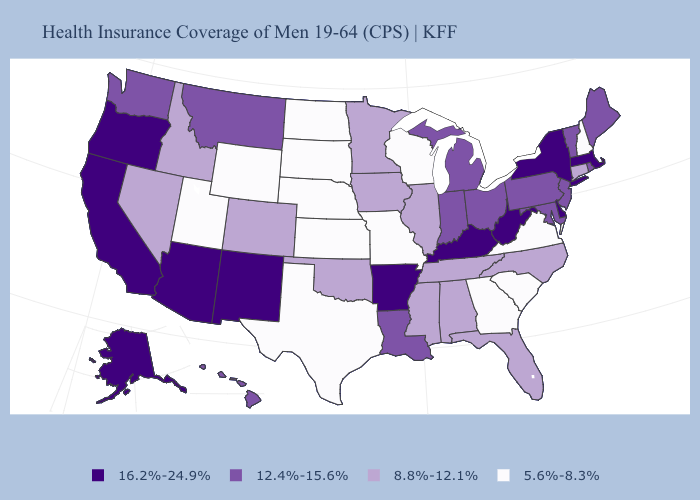Name the states that have a value in the range 5.6%-8.3%?
Concise answer only. Georgia, Kansas, Missouri, Nebraska, New Hampshire, North Dakota, South Carolina, South Dakota, Texas, Utah, Virginia, Wisconsin, Wyoming. What is the lowest value in the USA?
Be succinct. 5.6%-8.3%. Does West Virginia have the lowest value in the USA?
Keep it brief. No. Name the states that have a value in the range 16.2%-24.9%?
Short answer required. Alaska, Arizona, Arkansas, California, Delaware, Kentucky, Massachusetts, New Mexico, New York, Oregon, West Virginia. Name the states that have a value in the range 8.8%-12.1%?
Keep it brief. Alabama, Colorado, Connecticut, Florida, Idaho, Illinois, Iowa, Minnesota, Mississippi, Nevada, North Carolina, Oklahoma, Tennessee. What is the value of Texas?
Be succinct. 5.6%-8.3%. Among the states that border Colorado , which have the lowest value?
Short answer required. Kansas, Nebraska, Utah, Wyoming. Which states hav the highest value in the South?
Short answer required. Arkansas, Delaware, Kentucky, West Virginia. Among the states that border Vermont , does New Hampshire have the highest value?
Quick response, please. No. Name the states that have a value in the range 16.2%-24.9%?
Short answer required. Alaska, Arizona, Arkansas, California, Delaware, Kentucky, Massachusetts, New Mexico, New York, Oregon, West Virginia. Which states have the highest value in the USA?
Keep it brief. Alaska, Arizona, Arkansas, California, Delaware, Kentucky, Massachusetts, New Mexico, New York, Oregon, West Virginia. Does the first symbol in the legend represent the smallest category?
Give a very brief answer. No. Name the states that have a value in the range 12.4%-15.6%?
Keep it brief. Hawaii, Indiana, Louisiana, Maine, Maryland, Michigan, Montana, New Jersey, Ohio, Pennsylvania, Rhode Island, Vermont, Washington. Among the states that border Rhode Island , which have the highest value?
Concise answer only. Massachusetts. Does Illinois have a higher value than Maryland?
Answer briefly. No. 